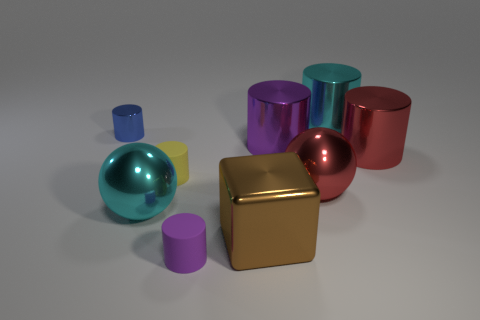What size is the cylinder that is the same material as the yellow object?
Offer a terse response. Small. What shape is the cyan metallic thing behind the large red metallic thing that is to the left of the big red metal cylinder?
Give a very brief answer. Cylinder. There is a cylinder that is on the left side of the brown shiny cube and on the right side of the tiny yellow cylinder; what is its size?
Offer a very short reply. Small. Is there a big red thing that has the same shape as the large purple metallic object?
Offer a very short reply. Yes. Are there any other things that have the same shape as the tiny yellow thing?
Your answer should be very brief. Yes. The large cyan object behind the tiny cylinder behind the big red metallic cylinder right of the cyan sphere is made of what material?
Keep it short and to the point. Metal. Are there any gray matte cubes of the same size as the cyan metal sphere?
Provide a succinct answer. No. What color is the shiny cylinder that is to the right of the object that is behind the small blue metallic object?
Keep it short and to the point. Red. What number of small gray rubber objects are there?
Give a very brief answer. 0. Are there fewer large brown shiny cubes in front of the brown metal object than cylinders left of the purple rubber cylinder?
Offer a terse response. Yes. 